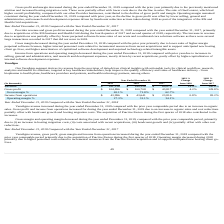According to Allscripts Healthcare Solutions's financial document, What led to increase in Veradigm revenue during the year ended December 31, 2019? due to an increase in organic sales.. The document states: "019 compared with the prior year comparable period due to an increase in organic sales. Gross profit and income from operations increased for during t..." Also, What led to increase in Gross profit and income from operations during the year ended December 31, 2019? due to an increase in organic sales and cost reductions partially offset with headcount growth and hosting migration costs.. The document states: "reased for during the year ended December 31, 2019 due to an increase in organic sales and cost reductions partially offset with headcount growth and ..." Also, What led to decrease in Gross margin and operating margin during the year ended December 31, 2019? (i) an increase in hosting migration costs, (ii) costs associated with recent acquisitions, (iii) headcount growth and (iv) partially offset with other cost reductions.. The document states: "due to (i) an increase in hosting migration costs, (ii) costs associated with recent acquisitions, (iii) headcount growth and (iv) partially offset wi..." Also, can you calculate: What is the change in Revenue between 2019 and 2017? Based on the calculation: 161,216-69,879, the result is 91337 (in thousands). This is based on the information: "Revenue $ 161,216 $ 140,326 $ 69,879 14.9% 100.8% Revenue $ 161,216 $ 140,326 $ 69,879 14.9% 100.8%..." The key data points involved are: 161,216, 69,879. Also, can you calculate: What is the change in Gross profit between 2019 nd 2017? Based on the calculation: 104,896-43,817, the result is 61079 (in thousands). This is based on the information: "Gross profit $ 104,896 $ 100,708 $ 43,817 4.2% 129.8% Gross profit $ 104,896 $ 100,708 $ 43,817 4.2% 129.8%..." The key data points involved are: 104,896, 43,817. Also, can you calculate: What is the change in Income from operations between 2019 and 2017? Based on the calculation: 43,996-23,816, the result is 20180 (in thousands). This is based on the information: "Income from operations $ 43,996 $ 43,641 $ 23,816 0.8% 83.2% Income from operations $ 43,996 $ 43,641 $ 23,816 0.8% 83.2%..." The key data points involved are: 23,816, 43,996. 